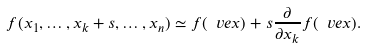Convert formula to latex. <formula><loc_0><loc_0><loc_500><loc_500>f ( x _ { 1 } , \dots , x _ { k } + s , \dots , x _ { n } ) \simeq f ( \ v e x ) + s \frac { \partial } { \partial x _ { k } } f ( \ v e x ) .</formula> 